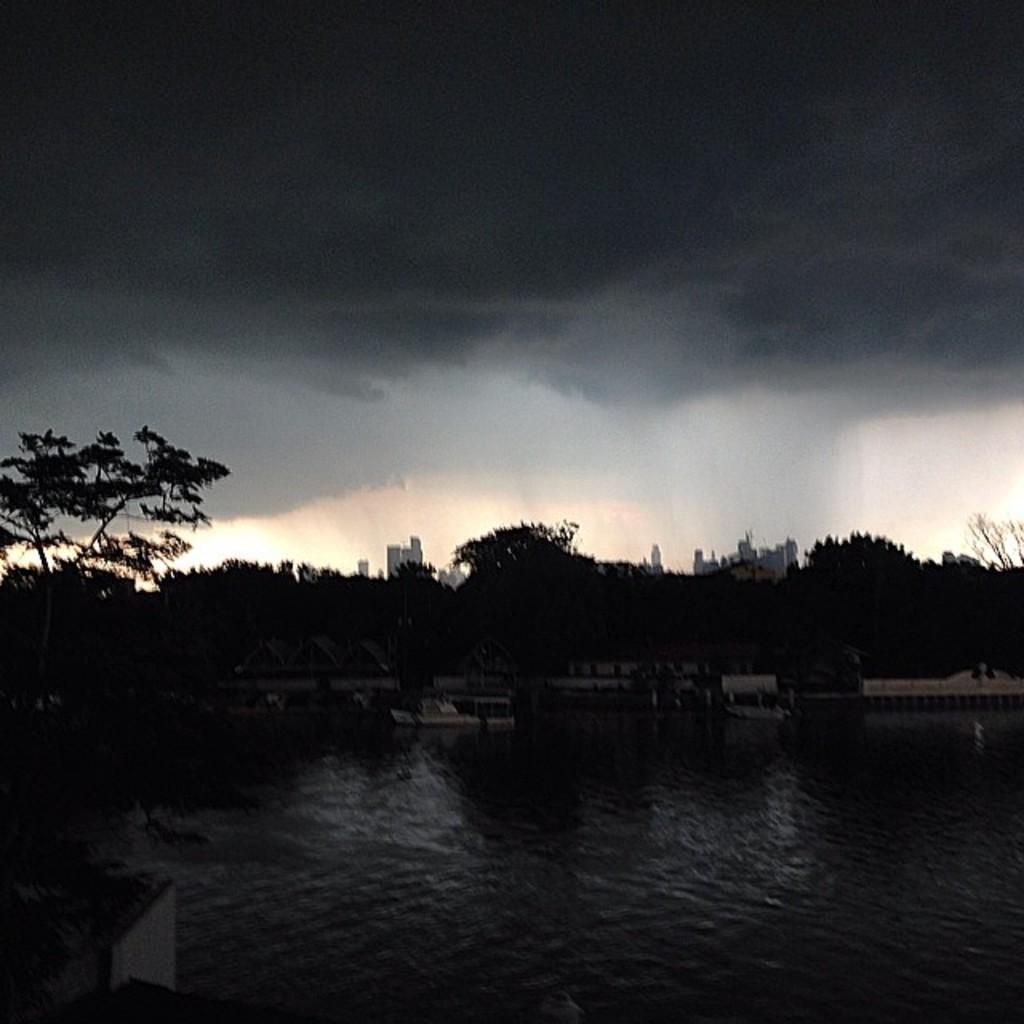What is the overall lighting condition in the image? The image is very dark. What natural element can be seen in the image? There is water visible in the image. What type of vegetation is present in the image? There are trees in the image. What man-made structures are visible in the image? There are boats and buildings in the image. What part of the natural environment is visible in the background of the image? The sky is visible in the background of the image. What type of club can be seen in the image? There is no club present in the image. What is the name of the downtown area visible in the image? There is no downtown area mentioned or visible in the image. 